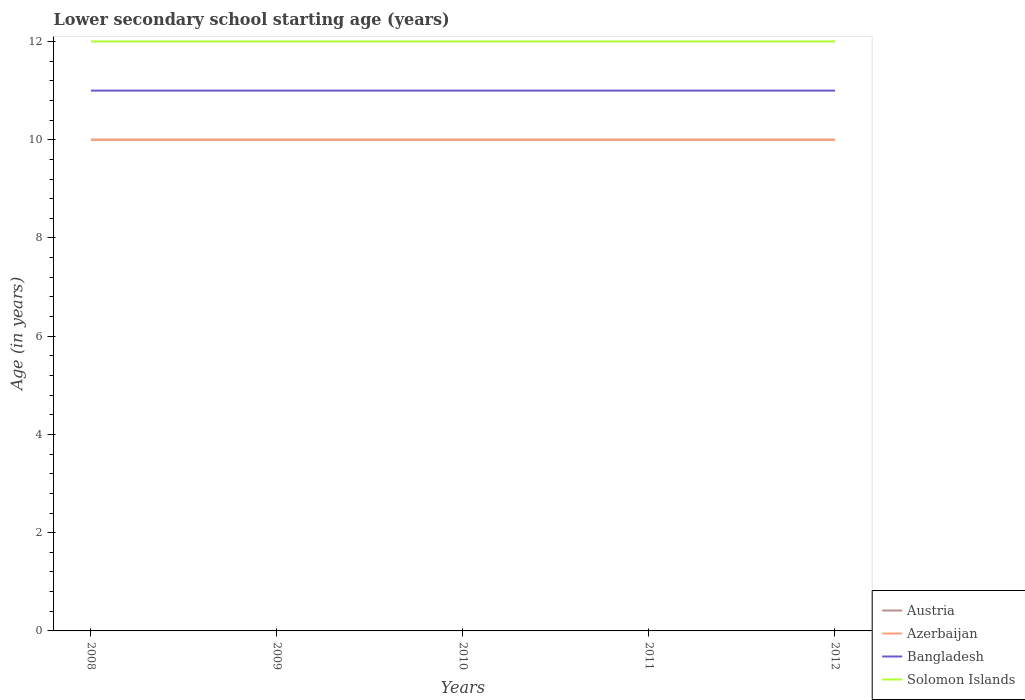How many different coloured lines are there?
Make the answer very short. 4. Does the line corresponding to Bangladesh intersect with the line corresponding to Austria?
Your response must be concise. No. Is the number of lines equal to the number of legend labels?
Your answer should be compact. Yes. Across all years, what is the maximum lower secondary school starting age of children in Solomon Islands?
Provide a succinct answer. 12. What is the difference between the highest and the second highest lower secondary school starting age of children in Azerbaijan?
Offer a terse response. 0. How many lines are there?
Keep it short and to the point. 4. How many years are there in the graph?
Your answer should be very brief. 5. Are the values on the major ticks of Y-axis written in scientific E-notation?
Your answer should be very brief. No. Does the graph contain any zero values?
Keep it short and to the point. No. Where does the legend appear in the graph?
Offer a very short reply. Bottom right. How many legend labels are there?
Provide a succinct answer. 4. How are the legend labels stacked?
Keep it short and to the point. Vertical. What is the title of the graph?
Offer a very short reply. Lower secondary school starting age (years). What is the label or title of the X-axis?
Your response must be concise. Years. What is the label or title of the Y-axis?
Give a very brief answer. Age (in years). What is the Age (in years) of Solomon Islands in 2008?
Your response must be concise. 12. What is the Age (in years) in Austria in 2009?
Give a very brief answer. 10. What is the Age (in years) of Azerbaijan in 2009?
Give a very brief answer. 10. What is the Age (in years) in Austria in 2010?
Offer a terse response. 10. What is the Age (in years) of Bangladesh in 2010?
Your answer should be compact. 11. What is the Age (in years) of Azerbaijan in 2011?
Your answer should be very brief. 10. What is the Age (in years) in Solomon Islands in 2011?
Provide a succinct answer. 12. What is the Age (in years) of Austria in 2012?
Provide a short and direct response. 10. What is the Age (in years) of Bangladesh in 2012?
Your answer should be very brief. 11. Across all years, what is the maximum Age (in years) in Austria?
Provide a succinct answer. 10. Across all years, what is the maximum Age (in years) of Solomon Islands?
Make the answer very short. 12. Across all years, what is the minimum Age (in years) of Austria?
Your answer should be very brief. 10. Across all years, what is the minimum Age (in years) of Azerbaijan?
Give a very brief answer. 10. What is the total Age (in years) in Austria in the graph?
Your answer should be very brief. 50. What is the total Age (in years) of Azerbaijan in the graph?
Your response must be concise. 50. What is the difference between the Age (in years) of Azerbaijan in 2008 and that in 2009?
Your answer should be very brief. 0. What is the difference between the Age (in years) of Bangladesh in 2008 and that in 2009?
Offer a terse response. 0. What is the difference between the Age (in years) in Solomon Islands in 2008 and that in 2009?
Give a very brief answer. 0. What is the difference between the Age (in years) in Austria in 2008 and that in 2010?
Ensure brevity in your answer.  0. What is the difference between the Age (in years) in Bangladesh in 2008 and that in 2010?
Keep it short and to the point. 0. What is the difference between the Age (in years) in Austria in 2008 and that in 2011?
Provide a succinct answer. 0. What is the difference between the Age (in years) in Bangladesh in 2008 and that in 2011?
Ensure brevity in your answer.  0. What is the difference between the Age (in years) of Solomon Islands in 2008 and that in 2011?
Offer a very short reply. 0. What is the difference between the Age (in years) of Bangladesh in 2008 and that in 2012?
Your response must be concise. 0. What is the difference between the Age (in years) in Solomon Islands in 2008 and that in 2012?
Offer a terse response. 0. What is the difference between the Age (in years) in Solomon Islands in 2009 and that in 2010?
Your answer should be compact. 0. What is the difference between the Age (in years) of Austria in 2009 and that in 2011?
Offer a terse response. 0. What is the difference between the Age (in years) of Azerbaijan in 2009 and that in 2011?
Offer a terse response. 0. What is the difference between the Age (in years) of Austria in 2009 and that in 2012?
Keep it short and to the point. 0. What is the difference between the Age (in years) of Azerbaijan in 2009 and that in 2012?
Make the answer very short. 0. What is the difference between the Age (in years) of Bangladesh in 2009 and that in 2012?
Provide a succinct answer. 0. What is the difference between the Age (in years) in Austria in 2010 and that in 2011?
Your answer should be compact. 0. What is the difference between the Age (in years) of Austria in 2010 and that in 2012?
Ensure brevity in your answer.  0. What is the difference between the Age (in years) in Solomon Islands in 2010 and that in 2012?
Ensure brevity in your answer.  0. What is the difference between the Age (in years) of Austria in 2011 and that in 2012?
Give a very brief answer. 0. What is the difference between the Age (in years) of Bangladesh in 2011 and that in 2012?
Offer a very short reply. 0. What is the difference between the Age (in years) of Solomon Islands in 2011 and that in 2012?
Offer a terse response. 0. What is the difference between the Age (in years) in Austria in 2008 and the Age (in years) in Azerbaijan in 2009?
Your answer should be very brief. 0. What is the difference between the Age (in years) in Austria in 2008 and the Age (in years) in Bangladesh in 2009?
Your answer should be compact. -1. What is the difference between the Age (in years) in Austria in 2008 and the Age (in years) in Solomon Islands in 2009?
Provide a short and direct response. -2. What is the difference between the Age (in years) in Bangladesh in 2008 and the Age (in years) in Solomon Islands in 2009?
Your answer should be compact. -1. What is the difference between the Age (in years) in Azerbaijan in 2008 and the Age (in years) in Solomon Islands in 2010?
Provide a short and direct response. -2. What is the difference between the Age (in years) in Bangladesh in 2008 and the Age (in years) in Solomon Islands in 2010?
Your response must be concise. -1. What is the difference between the Age (in years) in Austria in 2008 and the Age (in years) in Azerbaijan in 2011?
Your answer should be compact. 0. What is the difference between the Age (in years) in Austria in 2008 and the Age (in years) in Solomon Islands in 2011?
Keep it short and to the point. -2. What is the difference between the Age (in years) in Azerbaijan in 2008 and the Age (in years) in Solomon Islands in 2011?
Your answer should be very brief. -2. What is the difference between the Age (in years) of Bangladesh in 2008 and the Age (in years) of Solomon Islands in 2011?
Ensure brevity in your answer.  -1. What is the difference between the Age (in years) of Austria in 2008 and the Age (in years) of Azerbaijan in 2012?
Ensure brevity in your answer.  0. What is the difference between the Age (in years) in Austria in 2008 and the Age (in years) in Bangladesh in 2012?
Offer a terse response. -1. What is the difference between the Age (in years) in Azerbaijan in 2008 and the Age (in years) in Solomon Islands in 2012?
Offer a very short reply. -2. What is the difference between the Age (in years) in Bangladesh in 2008 and the Age (in years) in Solomon Islands in 2012?
Offer a terse response. -1. What is the difference between the Age (in years) of Austria in 2009 and the Age (in years) of Azerbaijan in 2010?
Your answer should be very brief. 0. What is the difference between the Age (in years) in Austria in 2009 and the Age (in years) in Solomon Islands in 2010?
Give a very brief answer. -2. What is the difference between the Age (in years) of Azerbaijan in 2009 and the Age (in years) of Bangladesh in 2010?
Offer a very short reply. -1. What is the difference between the Age (in years) in Austria in 2009 and the Age (in years) in Azerbaijan in 2011?
Provide a short and direct response. 0. What is the difference between the Age (in years) of Austria in 2009 and the Age (in years) of Bangladesh in 2011?
Make the answer very short. -1. What is the difference between the Age (in years) in Austria in 2009 and the Age (in years) in Solomon Islands in 2011?
Your response must be concise. -2. What is the difference between the Age (in years) in Azerbaijan in 2009 and the Age (in years) in Bangladesh in 2011?
Your answer should be very brief. -1. What is the difference between the Age (in years) of Austria in 2009 and the Age (in years) of Azerbaijan in 2012?
Your answer should be very brief. 0. What is the difference between the Age (in years) of Azerbaijan in 2009 and the Age (in years) of Bangladesh in 2012?
Provide a succinct answer. -1. What is the difference between the Age (in years) in Azerbaijan in 2009 and the Age (in years) in Solomon Islands in 2012?
Your answer should be compact. -2. What is the difference between the Age (in years) of Austria in 2010 and the Age (in years) of Azerbaijan in 2011?
Ensure brevity in your answer.  0. What is the difference between the Age (in years) of Austria in 2010 and the Age (in years) of Solomon Islands in 2011?
Provide a succinct answer. -2. What is the difference between the Age (in years) of Austria in 2010 and the Age (in years) of Bangladesh in 2012?
Keep it short and to the point. -1. What is the difference between the Age (in years) of Austria in 2010 and the Age (in years) of Solomon Islands in 2012?
Provide a short and direct response. -2. What is the difference between the Age (in years) of Azerbaijan in 2010 and the Age (in years) of Bangladesh in 2012?
Your answer should be compact. -1. What is the difference between the Age (in years) in Azerbaijan in 2010 and the Age (in years) in Solomon Islands in 2012?
Offer a very short reply. -2. What is the difference between the Age (in years) of Bangladesh in 2010 and the Age (in years) of Solomon Islands in 2012?
Offer a terse response. -1. What is the difference between the Age (in years) of Austria in 2011 and the Age (in years) of Azerbaijan in 2012?
Keep it short and to the point. 0. What is the difference between the Age (in years) in Austria in 2011 and the Age (in years) in Bangladesh in 2012?
Offer a very short reply. -1. What is the difference between the Age (in years) in Azerbaijan in 2011 and the Age (in years) in Solomon Islands in 2012?
Provide a succinct answer. -2. What is the average Age (in years) of Austria per year?
Offer a terse response. 10. What is the average Age (in years) of Azerbaijan per year?
Make the answer very short. 10. What is the average Age (in years) in Bangladesh per year?
Offer a very short reply. 11. In the year 2008, what is the difference between the Age (in years) of Austria and Age (in years) of Azerbaijan?
Give a very brief answer. 0. In the year 2008, what is the difference between the Age (in years) of Azerbaijan and Age (in years) of Bangladesh?
Provide a succinct answer. -1. In the year 2008, what is the difference between the Age (in years) of Azerbaijan and Age (in years) of Solomon Islands?
Offer a terse response. -2. In the year 2008, what is the difference between the Age (in years) in Bangladesh and Age (in years) in Solomon Islands?
Provide a succinct answer. -1. In the year 2009, what is the difference between the Age (in years) in Austria and Age (in years) in Azerbaijan?
Your answer should be very brief. 0. In the year 2009, what is the difference between the Age (in years) of Austria and Age (in years) of Solomon Islands?
Ensure brevity in your answer.  -2. In the year 2010, what is the difference between the Age (in years) in Austria and Age (in years) in Azerbaijan?
Ensure brevity in your answer.  0. In the year 2010, what is the difference between the Age (in years) of Austria and Age (in years) of Bangladesh?
Make the answer very short. -1. In the year 2010, what is the difference between the Age (in years) of Azerbaijan and Age (in years) of Bangladesh?
Give a very brief answer. -1. In the year 2010, what is the difference between the Age (in years) of Bangladesh and Age (in years) of Solomon Islands?
Give a very brief answer. -1. In the year 2011, what is the difference between the Age (in years) in Austria and Age (in years) in Solomon Islands?
Your answer should be very brief. -2. In the year 2011, what is the difference between the Age (in years) in Azerbaijan and Age (in years) in Bangladesh?
Give a very brief answer. -1. In the year 2011, what is the difference between the Age (in years) in Azerbaijan and Age (in years) in Solomon Islands?
Provide a short and direct response. -2. In the year 2012, what is the difference between the Age (in years) in Austria and Age (in years) in Bangladesh?
Make the answer very short. -1. In the year 2012, what is the difference between the Age (in years) of Austria and Age (in years) of Solomon Islands?
Provide a short and direct response. -2. What is the ratio of the Age (in years) in Solomon Islands in 2008 to that in 2009?
Provide a short and direct response. 1. What is the ratio of the Age (in years) in Austria in 2008 to that in 2010?
Your answer should be very brief. 1. What is the ratio of the Age (in years) in Bangladesh in 2008 to that in 2010?
Keep it short and to the point. 1. What is the ratio of the Age (in years) in Solomon Islands in 2008 to that in 2010?
Provide a short and direct response. 1. What is the ratio of the Age (in years) in Austria in 2008 to that in 2011?
Ensure brevity in your answer.  1. What is the ratio of the Age (in years) in Azerbaijan in 2008 to that in 2011?
Give a very brief answer. 1. What is the ratio of the Age (in years) in Bangladesh in 2008 to that in 2011?
Provide a short and direct response. 1. What is the ratio of the Age (in years) of Austria in 2008 to that in 2012?
Offer a very short reply. 1. What is the ratio of the Age (in years) of Bangladesh in 2008 to that in 2012?
Your response must be concise. 1. What is the ratio of the Age (in years) of Solomon Islands in 2008 to that in 2012?
Make the answer very short. 1. What is the ratio of the Age (in years) in Azerbaijan in 2009 to that in 2010?
Give a very brief answer. 1. What is the ratio of the Age (in years) of Bangladesh in 2009 to that in 2010?
Make the answer very short. 1. What is the ratio of the Age (in years) in Solomon Islands in 2009 to that in 2010?
Your answer should be compact. 1. What is the ratio of the Age (in years) of Azerbaijan in 2009 to that in 2011?
Offer a very short reply. 1. What is the ratio of the Age (in years) in Solomon Islands in 2009 to that in 2011?
Offer a very short reply. 1. What is the ratio of the Age (in years) of Austria in 2009 to that in 2012?
Ensure brevity in your answer.  1. What is the ratio of the Age (in years) of Azerbaijan in 2009 to that in 2012?
Provide a succinct answer. 1. What is the ratio of the Age (in years) of Solomon Islands in 2009 to that in 2012?
Your answer should be very brief. 1. What is the ratio of the Age (in years) of Austria in 2010 to that in 2011?
Ensure brevity in your answer.  1. What is the ratio of the Age (in years) in Bangladesh in 2010 to that in 2011?
Keep it short and to the point. 1. What is the ratio of the Age (in years) in Solomon Islands in 2010 to that in 2011?
Ensure brevity in your answer.  1. What is the ratio of the Age (in years) of Austria in 2011 to that in 2012?
Your answer should be very brief. 1. What is the ratio of the Age (in years) of Bangladesh in 2011 to that in 2012?
Keep it short and to the point. 1. What is the ratio of the Age (in years) of Solomon Islands in 2011 to that in 2012?
Your response must be concise. 1. What is the difference between the highest and the second highest Age (in years) in Azerbaijan?
Give a very brief answer. 0. What is the difference between the highest and the second highest Age (in years) in Bangladesh?
Ensure brevity in your answer.  0. What is the difference between the highest and the second highest Age (in years) of Solomon Islands?
Your answer should be very brief. 0. What is the difference between the highest and the lowest Age (in years) of Azerbaijan?
Your answer should be compact. 0. What is the difference between the highest and the lowest Age (in years) of Bangladesh?
Provide a succinct answer. 0. What is the difference between the highest and the lowest Age (in years) in Solomon Islands?
Offer a very short reply. 0. 